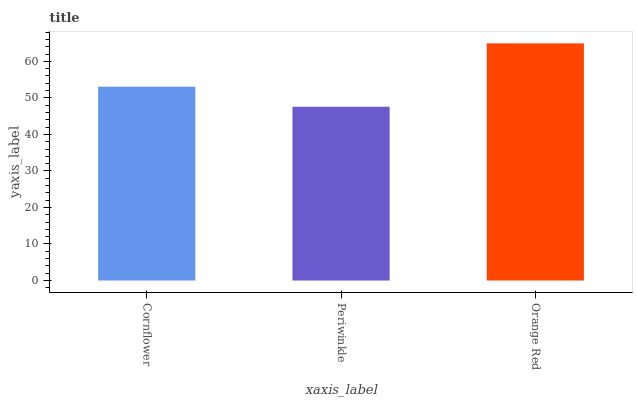Is Periwinkle the minimum?
Answer yes or no. Yes. Is Orange Red the maximum?
Answer yes or no. Yes. Is Orange Red the minimum?
Answer yes or no. No. Is Periwinkle the maximum?
Answer yes or no. No. Is Orange Red greater than Periwinkle?
Answer yes or no. Yes. Is Periwinkle less than Orange Red?
Answer yes or no. Yes. Is Periwinkle greater than Orange Red?
Answer yes or no. No. Is Orange Red less than Periwinkle?
Answer yes or no. No. Is Cornflower the high median?
Answer yes or no. Yes. Is Cornflower the low median?
Answer yes or no. Yes. Is Orange Red the high median?
Answer yes or no. No. Is Orange Red the low median?
Answer yes or no. No. 